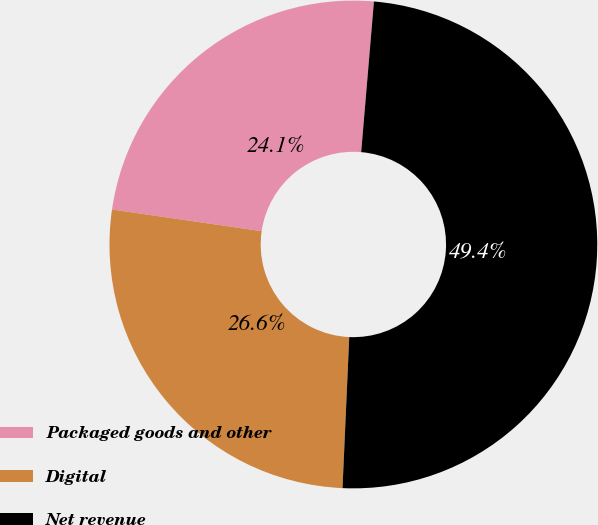Convert chart. <chart><loc_0><loc_0><loc_500><loc_500><pie_chart><fcel>Packaged goods and other<fcel>Digital<fcel>Net revenue<nl><fcel>24.05%<fcel>26.58%<fcel>49.36%<nl></chart> 